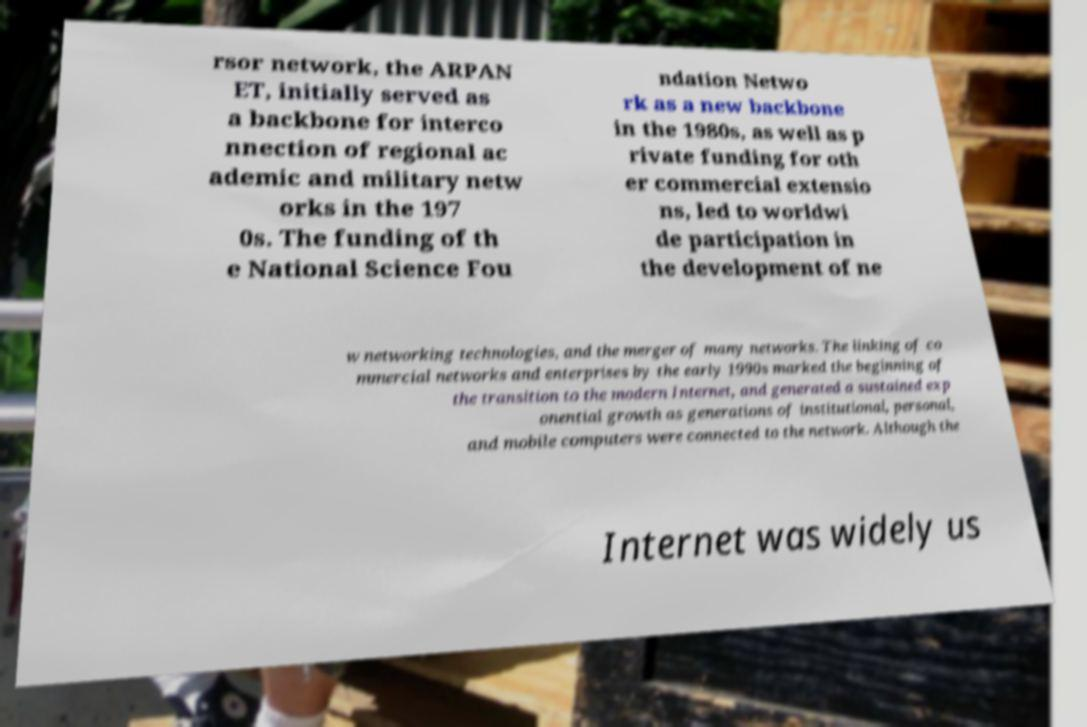Please identify and transcribe the text found in this image. rsor network, the ARPAN ET, initially served as a backbone for interco nnection of regional ac ademic and military netw orks in the 197 0s. The funding of th e National Science Fou ndation Netwo rk as a new backbone in the 1980s, as well as p rivate funding for oth er commercial extensio ns, led to worldwi de participation in the development of ne w networking technologies, and the merger of many networks. The linking of co mmercial networks and enterprises by the early 1990s marked the beginning of the transition to the modern Internet, and generated a sustained exp onential growth as generations of institutional, personal, and mobile computers were connected to the network. Although the Internet was widely us 